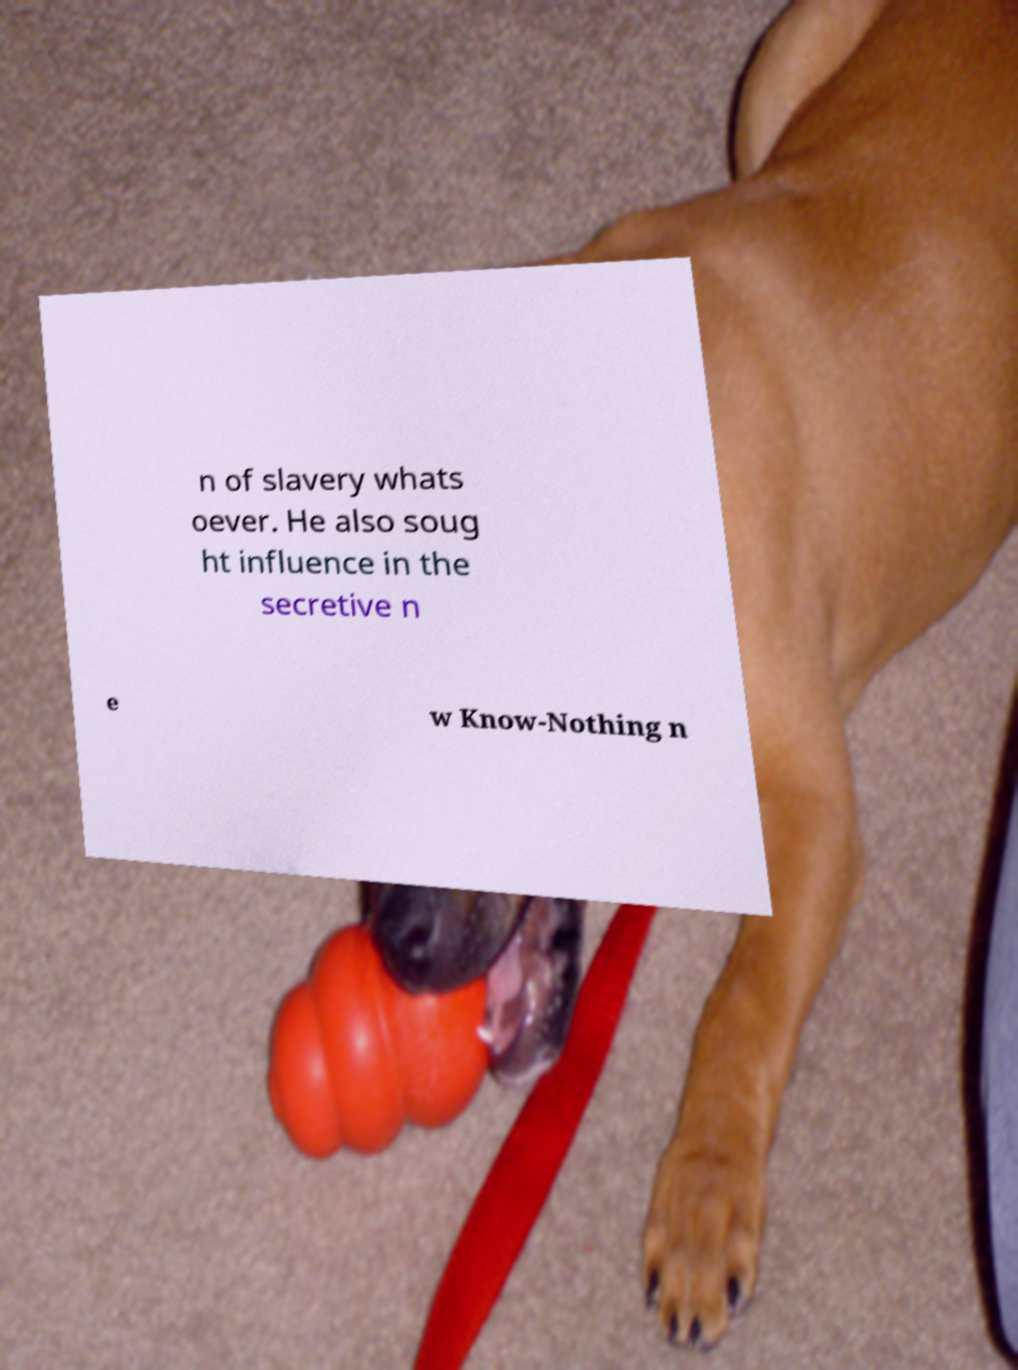Please identify and transcribe the text found in this image. n of slavery whats oever. He also soug ht influence in the secretive n e w Know-Nothing n 